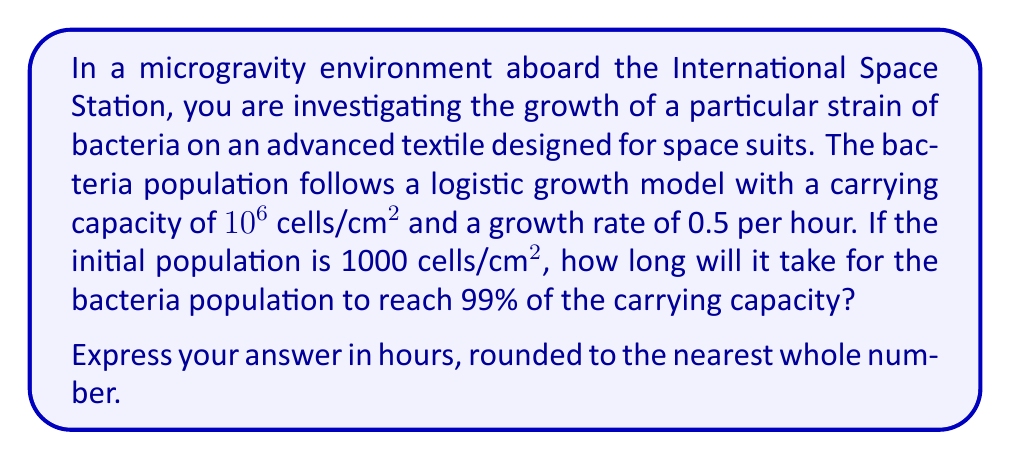What is the answer to this math problem? To solve this problem, we'll use the logistic growth model and its solution. The logistic growth model is given by the differential equation:

$$\frac{dP}{dt} = rP(1 - \frac{P}{K})$$

Where:
$P$ is the population
$t$ is time
$r$ is the growth rate
$K$ is the carrying capacity

The solution to this equation is:

$$P(t) = \frac{K}{1 + (\frac{K}{P_0} - 1)e^{-rt}}$$

Where $P_0$ is the initial population.

Given:
$K = 10^6$ cells/cm²
$r = 0.5$ per hour
$P_0 = 1000$ cells/cm²

We want to find $t$ when $P(t) = 0.99K = 0.99 \times 10^6$ cells/cm²

Let's substitute these values into the equation:

$$0.99 \times 10^6 = \frac{10^6}{1 + (\frac{10^6}{1000} - 1)e^{-0.5t}}$$

Simplify:

$$0.99 = \frac{1}{1 + 999e^{-0.5t}}$$

Solve for $t$:

$$\frac{1}{0.99} = 1 + 999e^{-0.5t}$$
$$\frac{1}{0.99} - 1 = 999e^{-0.5t}$$
$$\frac{1}{99} = 999e^{-0.5t}$$
$$\frac{1}{99 \times 999} = e^{-0.5t}$$
$$\ln(\frac{1}{99 \times 999}) = -0.5t$$
$$\frac{-2\ln(\frac{1}{99 \times 999})}{0.5} = t$$

Calculating this value:

$$t \approx 18.42 \text{ hours}$$

Rounding to the nearest whole number, we get 18 hours.
Answer: 18 hours 